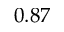Convert formula to latex. <formula><loc_0><loc_0><loc_500><loc_500>0 . 8 7</formula> 